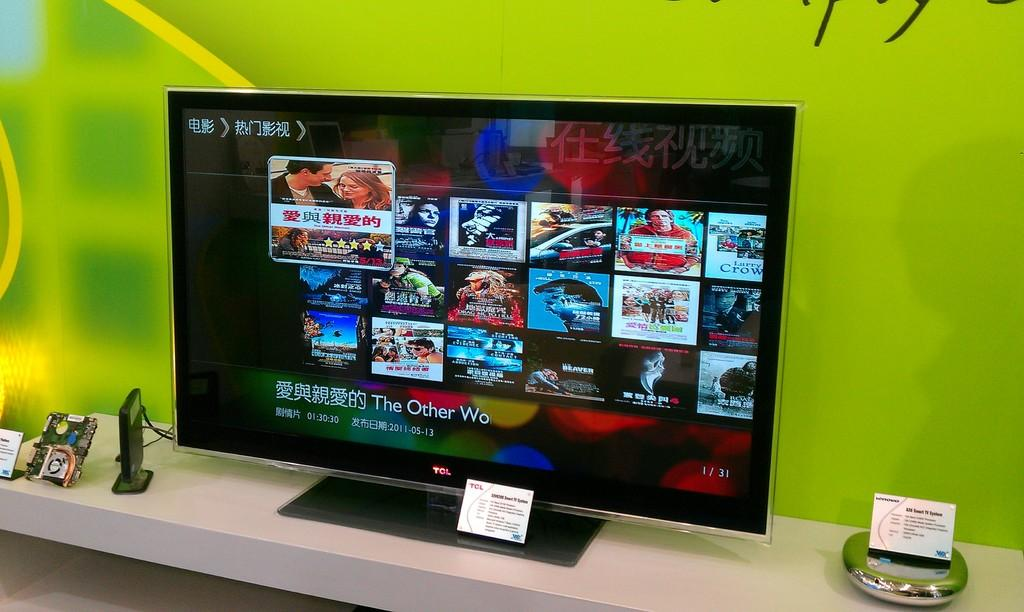<image>
Share a concise interpretation of the image provided. A widescreen television has a glowing TCL identifier on its border. 